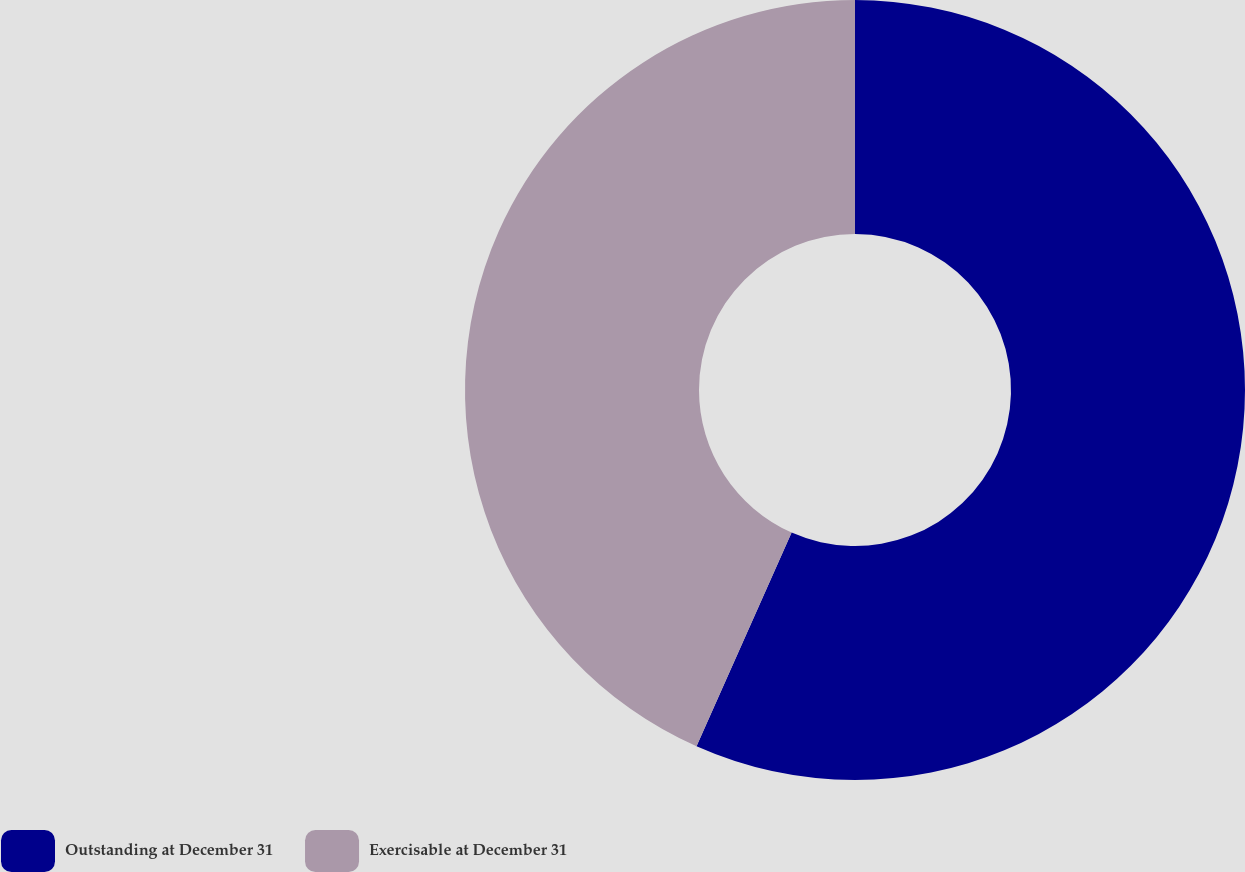Convert chart to OTSL. <chart><loc_0><loc_0><loc_500><loc_500><pie_chart><fcel>Outstanding at December 31<fcel>Exercisable at December 31<nl><fcel>56.66%<fcel>43.34%<nl></chart> 